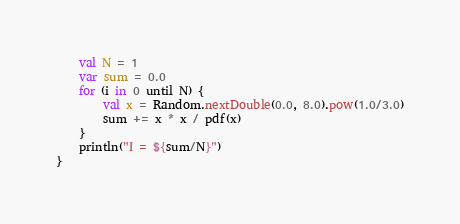Convert code to text. <code><loc_0><loc_0><loc_500><loc_500><_Kotlin_>    val N = 1
    var sum = 0.0
    for (i in 0 until N) {
        val x = Random.nextDouble(0.0, 8.0).pow(1.0/3.0)
        sum += x * x / pdf(x)
    }
    println("I = ${sum/N}")
}
</code> 